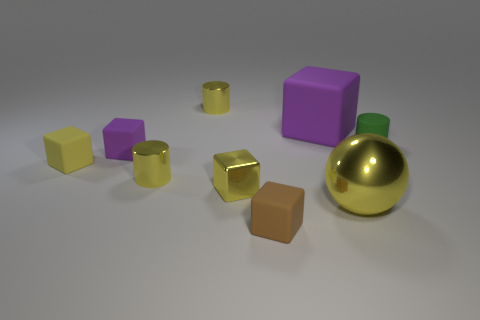Subtract all brown blocks. How many blocks are left? 4 Subtract all blue cubes. Subtract all purple balls. How many cubes are left? 5 Add 1 tiny cyan spheres. How many objects exist? 10 Subtract all blocks. How many objects are left? 4 Add 3 large matte spheres. How many large matte spheres exist? 3 Subtract 0 blue spheres. How many objects are left? 9 Subtract all tiny yellow metal blocks. Subtract all yellow metallic balls. How many objects are left? 7 Add 1 yellow matte things. How many yellow matte things are left? 2 